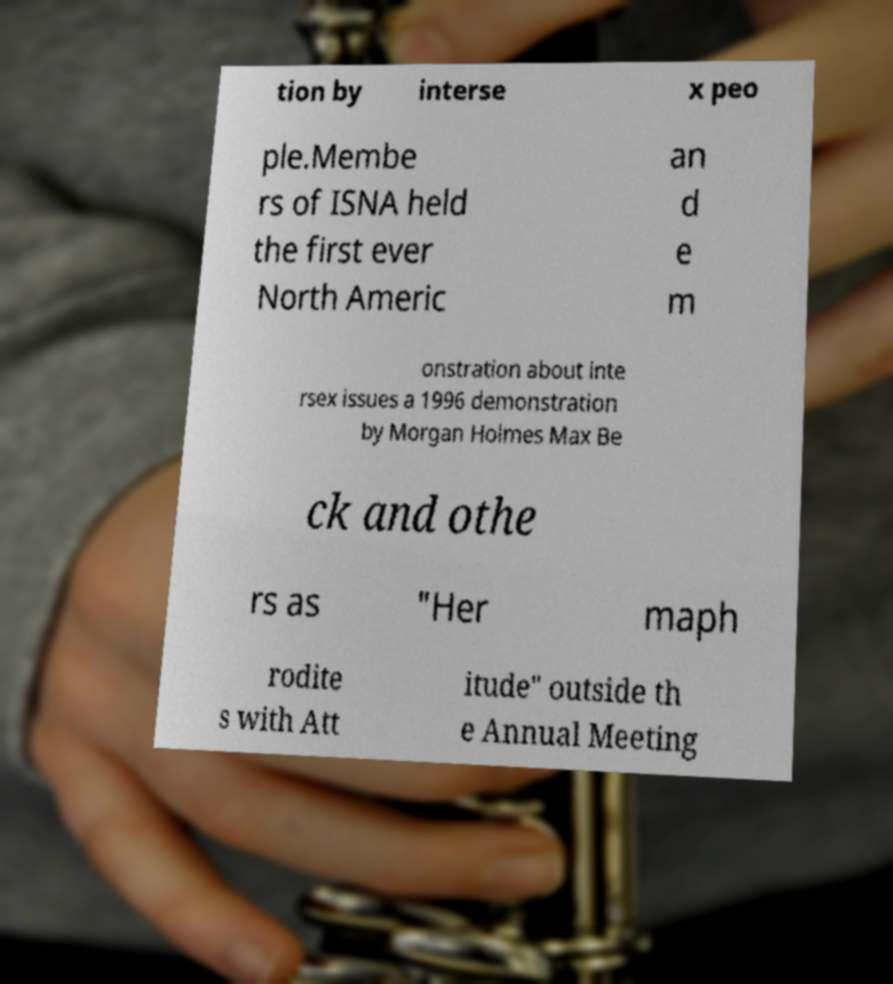Can you read and provide the text displayed in the image?This photo seems to have some interesting text. Can you extract and type it out for me? tion by interse x peo ple.Membe rs of ISNA held the first ever North Americ an d e m onstration about inte rsex issues a 1996 demonstration by Morgan Holmes Max Be ck and othe rs as "Her maph rodite s with Att itude" outside th e Annual Meeting 